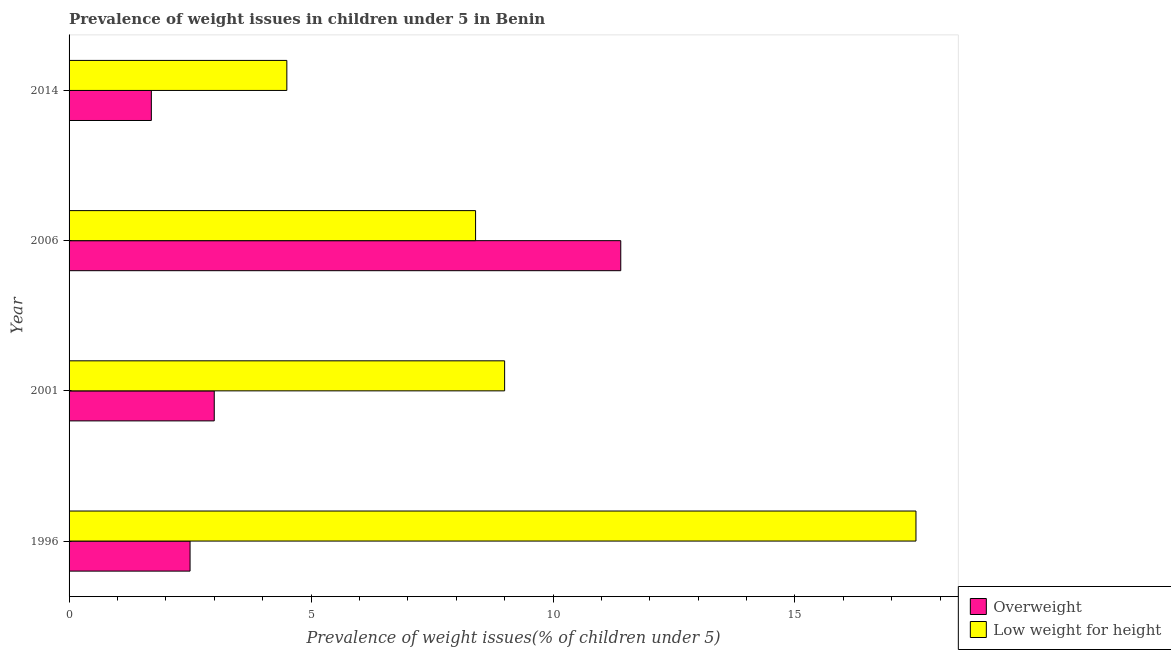How many different coloured bars are there?
Your answer should be compact. 2. Are the number of bars on each tick of the Y-axis equal?
Offer a terse response. Yes. In how many cases, is the number of bars for a given year not equal to the number of legend labels?
Offer a terse response. 0. Across all years, what is the maximum percentage of overweight children?
Make the answer very short. 11.4. In which year was the percentage of overweight children minimum?
Offer a terse response. 2014. What is the total percentage of underweight children in the graph?
Keep it short and to the point. 39.4. What is the difference between the percentage of underweight children in 1996 and the percentage of overweight children in 2006?
Your answer should be very brief. 6.1. What is the average percentage of underweight children per year?
Provide a succinct answer. 9.85. In the year 1996, what is the difference between the percentage of overweight children and percentage of underweight children?
Make the answer very short. -15. What is the ratio of the percentage of underweight children in 2006 to that in 2014?
Offer a very short reply. 1.87. Is the percentage of overweight children in 1996 less than that in 2014?
Your response must be concise. No. What is the difference between the highest and the second highest percentage of overweight children?
Offer a terse response. 8.4. What is the difference between the highest and the lowest percentage of underweight children?
Ensure brevity in your answer.  13. In how many years, is the percentage of underweight children greater than the average percentage of underweight children taken over all years?
Keep it short and to the point. 1. Is the sum of the percentage of overweight children in 2001 and 2014 greater than the maximum percentage of underweight children across all years?
Give a very brief answer. No. What does the 1st bar from the top in 2006 represents?
Keep it short and to the point. Low weight for height. What does the 1st bar from the bottom in 2001 represents?
Offer a very short reply. Overweight. Are all the bars in the graph horizontal?
Provide a succinct answer. Yes. What is the difference between two consecutive major ticks on the X-axis?
Provide a succinct answer. 5. Does the graph contain any zero values?
Your response must be concise. No. Does the graph contain grids?
Provide a short and direct response. No. How many legend labels are there?
Your response must be concise. 2. How are the legend labels stacked?
Keep it short and to the point. Vertical. What is the title of the graph?
Offer a terse response. Prevalence of weight issues in children under 5 in Benin. Does "Pregnant women" appear as one of the legend labels in the graph?
Your response must be concise. No. What is the label or title of the X-axis?
Your answer should be compact. Prevalence of weight issues(% of children under 5). What is the Prevalence of weight issues(% of children under 5) in Overweight in 2001?
Give a very brief answer. 3. What is the Prevalence of weight issues(% of children under 5) of Overweight in 2006?
Offer a terse response. 11.4. What is the Prevalence of weight issues(% of children under 5) in Low weight for height in 2006?
Make the answer very short. 8.4. What is the Prevalence of weight issues(% of children under 5) in Overweight in 2014?
Keep it short and to the point. 1.7. Across all years, what is the maximum Prevalence of weight issues(% of children under 5) of Overweight?
Offer a very short reply. 11.4. Across all years, what is the maximum Prevalence of weight issues(% of children under 5) of Low weight for height?
Keep it short and to the point. 17.5. Across all years, what is the minimum Prevalence of weight issues(% of children under 5) of Overweight?
Ensure brevity in your answer.  1.7. Across all years, what is the minimum Prevalence of weight issues(% of children under 5) in Low weight for height?
Provide a succinct answer. 4.5. What is the total Prevalence of weight issues(% of children under 5) of Low weight for height in the graph?
Make the answer very short. 39.4. What is the difference between the Prevalence of weight issues(% of children under 5) in Low weight for height in 1996 and that in 2001?
Your answer should be compact. 8.5. What is the difference between the Prevalence of weight issues(% of children under 5) in Overweight in 1996 and that in 2006?
Provide a short and direct response. -8.9. What is the difference between the Prevalence of weight issues(% of children under 5) of Overweight in 1996 and that in 2014?
Your answer should be compact. 0.8. What is the difference between the Prevalence of weight issues(% of children under 5) of Low weight for height in 1996 and that in 2014?
Provide a short and direct response. 13. What is the difference between the Prevalence of weight issues(% of children under 5) of Low weight for height in 2001 and that in 2006?
Offer a very short reply. 0.6. What is the difference between the Prevalence of weight issues(% of children under 5) in Overweight in 2001 and that in 2014?
Keep it short and to the point. 1.3. What is the difference between the Prevalence of weight issues(% of children under 5) in Overweight in 2006 and that in 2014?
Your answer should be very brief. 9.7. What is the difference between the Prevalence of weight issues(% of children under 5) in Low weight for height in 2006 and that in 2014?
Your response must be concise. 3.9. What is the difference between the Prevalence of weight issues(% of children under 5) of Overweight in 1996 and the Prevalence of weight issues(% of children under 5) of Low weight for height in 2006?
Your answer should be very brief. -5.9. What is the difference between the Prevalence of weight issues(% of children under 5) in Overweight in 1996 and the Prevalence of weight issues(% of children under 5) in Low weight for height in 2014?
Your response must be concise. -2. What is the difference between the Prevalence of weight issues(% of children under 5) of Overweight in 2001 and the Prevalence of weight issues(% of children under 5) of Low weight for height in 2006?
Keep it short and to the point. -5.4. What is the difference between the Prevalence of weight issues(% of children under 5) of Overweight in 2006 and the Prevalence of weight issues(% of children under 5) of Low weight for height in 2014?
Offer a very short reply. 6.9. What is the average Prevalence of weight issues(% of children under 5) in Overweight per year?
Make the answer very short. 4.65. What is the average Prevalence of weight issues(% of children under 5) of Low weight for height per year?
Offer a terse response. 9.85. In the year 2001, what is the difference between the Prevalence of weight issues(% of children under 5) in Overweight and Prevalence of weight issues(% of children under 5) in Low weight for height?
Make the answer very short. -6. What is the ratio of the Prevalence of weight issues(% of children under 5) in Overweight in 1996 to that in 2001?
Keep it short and to the point. 0.83. What is the ratio of the Prevalence of weight issues(% of children under 5) of Low weight for height in 1996 to that in 2001?
Offer a very short reply. 1.94. What is the ratio of the Prevalence of weight issues(% of children under 5) of Overweight in 1996 to that in 2006?
Your answer should be compact. 0.22. What is the ratio of the Prevalence of weight issues(% of children under 5) of Low weight for height in 1996 to that in 2006?
Make the answer very short. 2.08. What is the ratio of the Prevalence of weight issues(% of children under 5) in Overweight in 1996 to that in 2014?
Keep it short and to the point. 1.47. What is the ratio of the Prevalence of weight issues(% of children under 5) in Low weight for height in 1996 to that in 2014?
Your response must be concise. 3.89. What is the ratio of the Prevalence of weight issues(% of children under 5) in Overweight in 2001 to that in 2006?
Make the answer very short. 0.26. What is the ratio of the Prevalence of weight issues(% of children under 5) in Low weight for height in 2001 to that in 2006?
Your answer should be very brief. 1.07. What is the ratio of the Prevalence of weight issues(% of children under 5) in Overweight in 2001 to that in 2014?
Keep it short and to the point. 1.76. What is the ratio of the Prevalence of weight issues(% of children under 5) in Low weight for height in 2001 to that in 2014?
Provide a short and direct response. 2. What is the ratio of the Prevalence of weight issues(% of children under 5) of Overweight in 2006 to that in 2014?
Provide a succinct answer. 6.71. What is the ratio of the Prevalence of weight issues(% of children under 5) in Low weight for height in 2006 to that in 2014?
Your answer should be very brief. 1.87. What is the difference between the highest and the lowest Prevalence of weight issues(% of children under 5) in Overweight?
Keep it short and to the point. 9.7. 